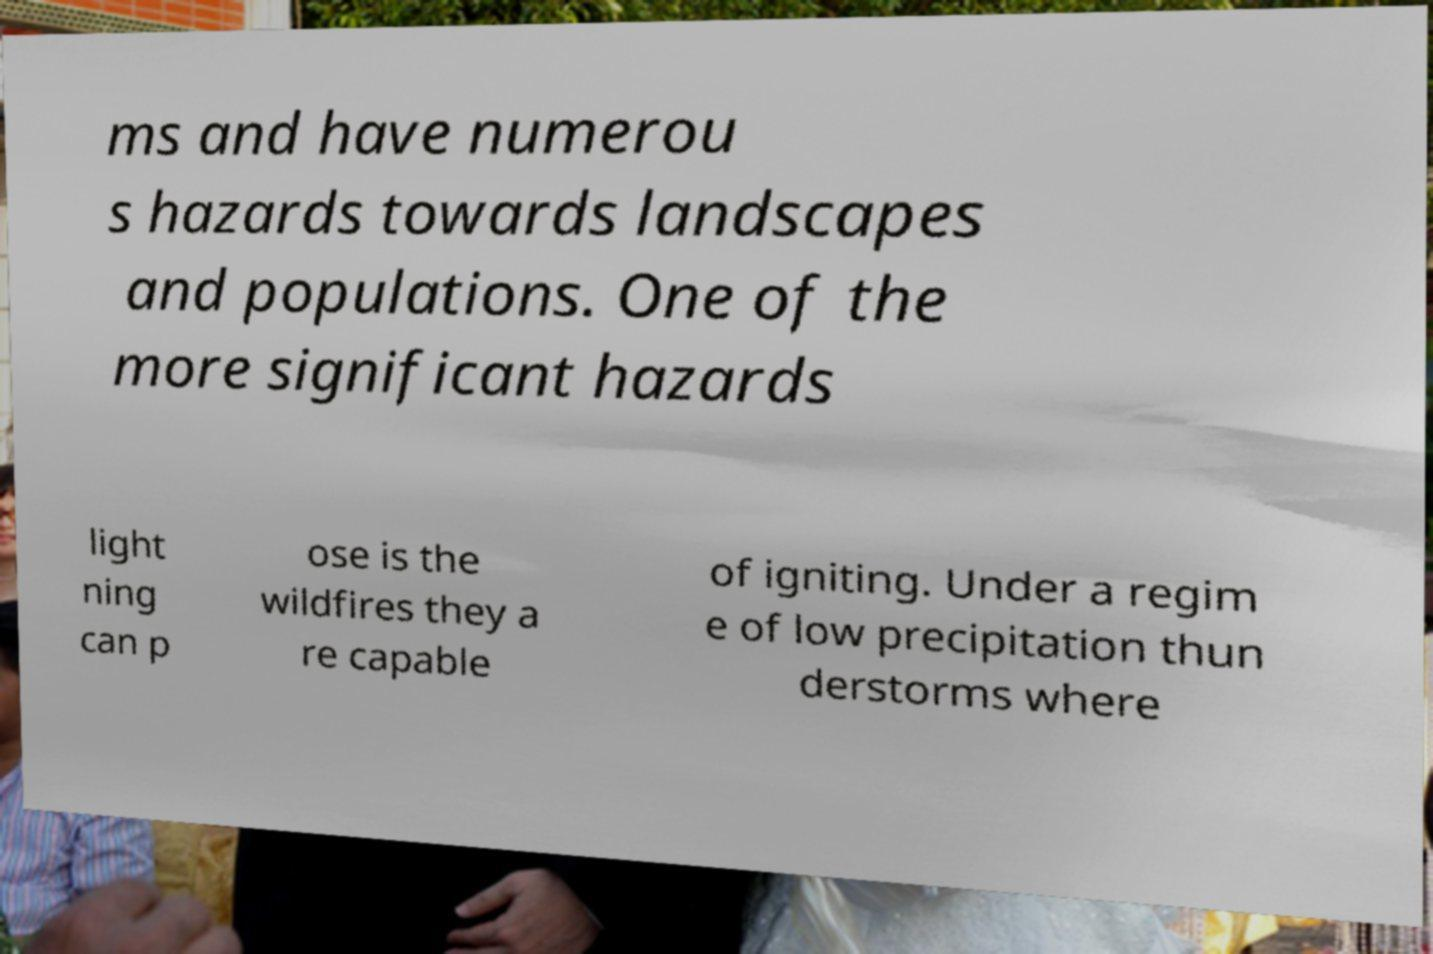Please identify and transcribe the text found in this image. ms and have numerou s hazards towards landscapes and populations. One of the more significant hazards light ning can p ose is the wildfires they a re capable of igniting. Under a regim e of low precipitation thun derstorms where 